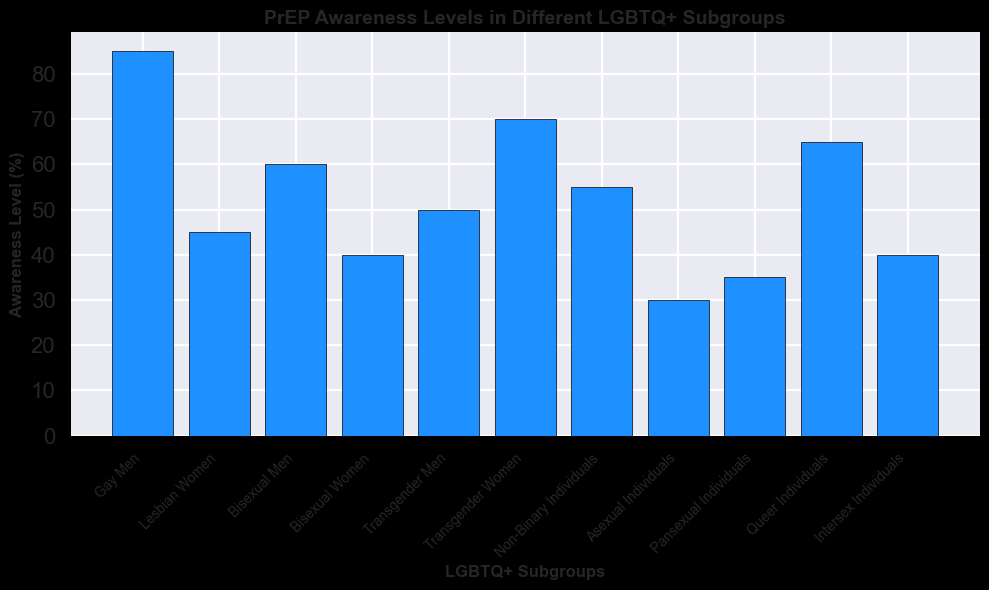Which group has the highest awareness level of PrEP? By looking at the height of the bars, Gay Men have the tallest bar, indicating the highest awareness level.
Answer: Gay Men Which group has the lowest awareness level of PrEP? By looking at the height of the bars, Asexual Individuals have the shortest bar, indicating the lowest awareness level.
Answer: Asexual Individuals How much higher is the awareness level in Gay Men compared to Asexual Individuals? The awareness level of Gay Men is 85%, and the awareness level of Asexual Individuals is 30%. The difference is 85% - 30%.
Answer: 55% Which group has an awareness level equal to or greater than 70%? By identifying the bar heights, Gay Men (85%) and Transgender Women (70%) have awareness levels equal to or greater than 70%.
Answer: Gay Men, Transgender Women What is the average awareness level across all subgroups? Sum the awareness levels of all subgroups and divide by the number of subgroups (85 + 45 + 60 + 40 + 50 + 70 + 55 + 30 + 35 + 65 + 40 = 575; 575 / 11 ≈ 52.27%).
Answer: Approx. 52.27% Is the awareness level of Bisexual Men higher than that of Transgender Men? The awareness level of Bisexual Men is 60%, and the awareness level of Transgender Men is 50%. 60% is higher than 50%.
Answer: Yes Which group, among Bisexual Women and Lesbian Women, has a higher awareness level? The bar representing Lesbian Women is taller than the bar representing Bisexual Women, indicating a higher awareness level of 45% compared to 40%.
Answer: Lesbian Women What is the difference in awareness levels between Queer Individuals and Pansexual Individuals? The awareness level of Queer Individuals is 65%, and Pansexual Individuals is 35%. The difference is 65% - 35%.
Answer: 30% What is the median awareness level among the LGBTQ+ subgroups? Arrange the awareness levels in ascending order (30, 35, 40, 40, 45, 50, 55, 60, 65, 70, 85); the middle value in this ordered list is 50%.
Answer: 50% Is the awareness level of Transgender Women greater than the awareness level of Bisexual Men? The awareness level of Transgender Women is 70%, and that of Bisexual Men is 60%. 70% is greater than 60%.
Answer: Yes 